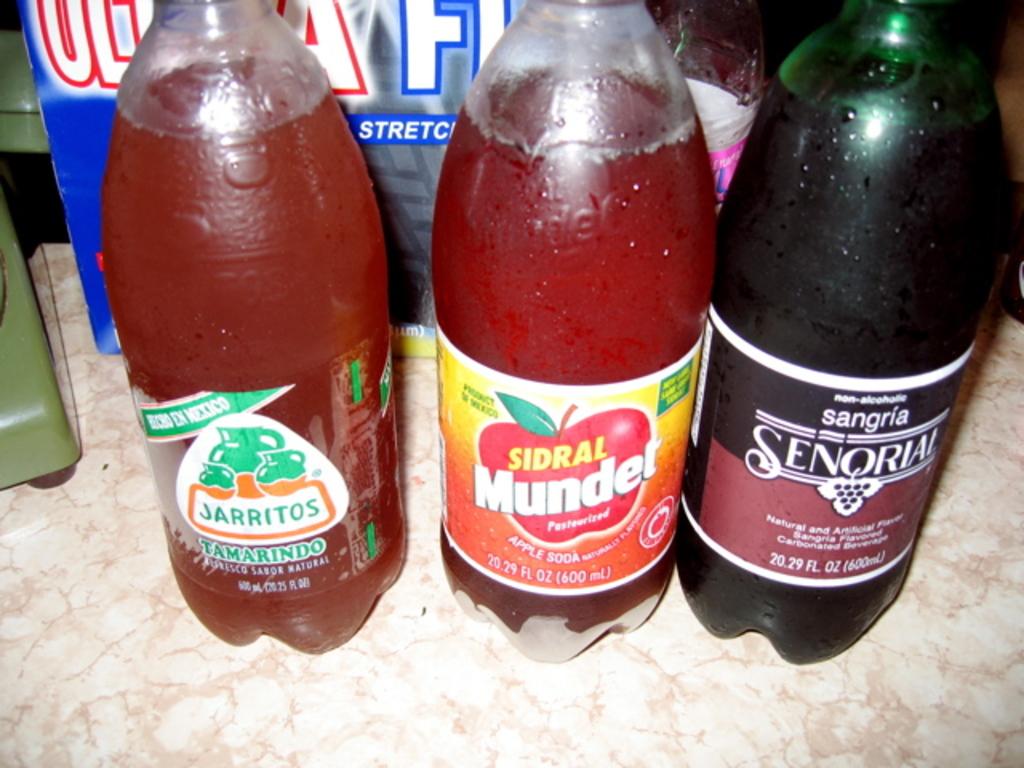What is the name of the soda in the middle?
Your answer should be compact. Sidral munder. What is the brand on the right?
Your response must be concise. Senorial. 